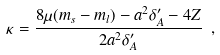Convert formula to latex. <formula><loc_0><loc_0><loc_500><loc_500>\kappa = \frac { 8 \mu ( m _ { s } - m _ { l } ) - a ^ { 2 } \delta ^ { \prime } _ { A } - 4 Z } { 2 a ^ { 2 } \delta ^ { \prime } _ { A } } \ ,</formula> 